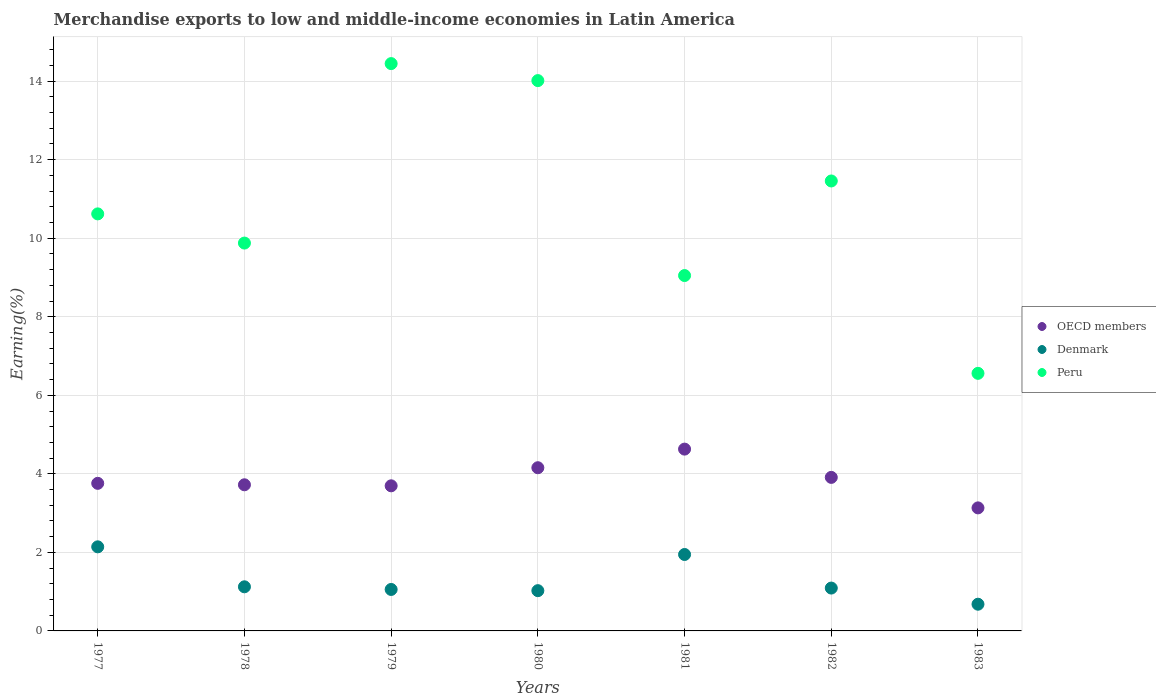What is the percentage of amount earned from merchandise exports in OECD members in 1982?
Provide a short and direct response. 3.91. Across all years, what is the maximum percentage of amount earned from merchandise exports in OECD members?
Your answer should be compact. 4.63. Across all years, what is the minimum percentage of amount earned from merchandise exports in OECD members?
Offer a terse response. 3.13. In which year was the percentage of amount earned from merchandise exports in OECD members maximum?
Offer a very short reply. 1981. In which year was the percentage of amount earned from merchandise exports in OECD members minimum?
Make the answer very short. 1983. What is the total percentage of amount earned from merchandise exports in OECD members in the graph?
Offer a very short reply. 27. What is the difference between the percentage of amount earned from merchandise exports in Peru in 1980 and that in 1982?
Your answer should be very brief. 2.56. What is the difference between the percentage of amount earned from merchandise exports in Peru in 1980 and the percentage of amount earned from merchandise exports in Denmark in 1982?
Make the answer very short. 12.92. What is the average percentage of amount earned from merchandise exports in Peru per year?
Ensure brevity in your answer.  10.86. In the year 1977, what is the difference between the percentage of amount earned from merchandise exports in Denmark and percentage of amount earned from merchandise exports in OECD members?
Provide a succinct answer. -1.62. What is the ratio of the percentage of amount earned from merchandise exports in OECD members in 1979 to that in 1983?
Offer a terse response. 1.18. Is the percentage of amount earned from merchandise exports in Peru in 1979 less than that in 1982?
Your answer should be compact. No. Is the difference between the percentage of amount earned from merchandise exports in Denmark in 1979 and 1983 greater than the difference between the percentage of amount earned from merchandise exports in OECD members in 1979 and 1983?
Give a very brief answer. No. What is the difference between the highest and the second highest percentage of amount earned from merchandise exports in Denmark?
Provide a succinct answer. 0.2. What is the difference between the highest and the lowest percentage of amount earned from merchandise exports in Peru?
Make the answer very short. 7.89. In how many years, is the percentage of amount earned from merchandise exports in OECD members greater than the average percentage of amount earned from merchandise exports in OECD members taken over all years?
Give a very brief answer. 3. Is the sum of the percentage of amount earned from merchandise exports in Denmark in 1977 and 1980 greater than the maximum percentage of amount earned from merchandise exports in Peru across all years?
Offer a terse response. No. Does the percentage of amount earned from merchandise exports in Peru monotonically increase over the years?
Ensure brevity in your answer.  No. Is the percentage of amount earned from merchandise exports in Denmark strictly greater than the percentage of amount earned from merchandise exports in Peru over the years?
Offer a very short reply. No. Is the percentage of amount earned from merchandise exports in Peru strictly less than the percentage of amount earned from merchandise exports in Denmark over the years?
Make the answer very short. No. How many years are there in the graph?
Provide a succinct answer. 7. Does the graph contain any zero values?
Make the answer very short. No. Does the graph contain grids?
Offer a very short reply. Yes. What is the title of the graph?
Keep it short and to the point. Merchandise exports to low and middle-income economies in Latin America. What is the label or title of the Y-axis?
Keep it short and to the point. Earning(%). What is the Earning(%) of OECD members in 1977?
Offer a very short reply. 3.76. What is the Earning(%) of Denmark in 1977?
Keep it short and to the point. 2.14. What is the Earning(%) of Peru in 1977?
Offer a very short reply. 10.62. What is the Earning(%) in OECD members in 1978?
Your answer should be compact. 3.72. What is the Earning(%) in Denmark in 1978?
Your response must be concise. 1.12. What is the Earning(%) in Peru in 1978?
Keep it short and to the point. 9.88. What is the Earning(%) in OECD members in 1979?
Your answer should be compact. 3.7. What is the Earning(%) in Denmark in 1979?
Provide a short and direct response. 1.06. What is the Earning(%) in Peru in 1979?
Offer a terse response. 14.45. What is the Earning(%) in OECD members in 1980?
Keep it short and to the point. 4.16. What is the Earning(%) in Denmark in 1980?
Ensure brevity in your answer.  1.03. What is the Earning(%) in Peru in 1980?
Your answer should be very brief. 14.01. What is the Earning(%) of OECD members in 1981?
Provide a succinct answer. 4.63. What is the Earning(%) in Denmark in 1981?
Your answer should be compact. 1.95. What is the Earning(%) in Peru in 1981?
Provide a short and direct response. 9.05. What is the Earning(%) in OECD members in 1982?
Provide a succinct answer. 3.91. What is the Earning(%) in Denmark in 1982?
Offer a very short reply. 1.09. What is the Earning(%) in Peru in 1982?
Your answer should be very brief. 11.46. What is the Earning(%) in OECD members in 1983?
Give a very brief answer. 3.13. What is the Earning(%) of Denmark in 1983?
Offer a very short reply. 0.68. What is the Earning(%) in Peru in 1983?
Offer a terse response. 6.56. Across all years, what is the maximum Earning(%) in OECD members?
Your answer should be compact. 4.63. Across all years, what is the maximum Earning(%) in Denmark?
Your answer should be compact. 2.14. Across all years, what is the maximum Earning(%) in Peru?
Provide a succinct answer. 14.45. Across all years, what is the minimum Earning(%) in OECD members?
Ensure brevity in your answer.  3.13. Across all years, what is the minimum Earning(%) in Denmark?
Make the answer very short. 0.68. Across all years, what is the minimum Earning(%) of Peru?
Keep it short and to the point. 6.56. What is the total Earning(%) of OECD members in the graph?
Provide a succinct answer. 27. What is the total Earning(%) in Denmark in the graph?
Make the answer very short. 9.06. What is the total Earning(%) of Peru in the graph?
Give a very brief answer. 76.03. What is the difference between the Earning(%) in OECD members in 1977 and that in 1978?
Keep it short and to the point. 0.04. What is the difference between the Earning(%) of Denmark in 1977 and that in 1978?
Your response must be concise. 1.02. What is the difference between the Earning(%) in Peru in 1977 and that in 1978?
Your answer should be compact. 0.74. What is the difference between the Earning(%) in OECD members in 1977 and that in 1979?
Offer a very short reply. 0.06. What is the difference between the Earning(%) of Denmark in 1977 and that in 1979?
Offer a very short reply. 1.09. What is the difference between the Earning(%) in Peru in 1977 and that in 1979?
Your response must be concise. -3.83. What is the difference between the Earning(%) of OECD members in 1977 and that in 1980?
Give a very brief answer. -0.4. What is the difference between the Earning(%) of Denmark in 1977 and that in 1980?
Ensure brevity in your answer.  1.12. What is the difference between the Earning(%) in Peru in 1977 and that in 1980?
Your answer should be compact. -3.39. What is the difference between the Earning(%) in OECD members in 1977 and that in 1981?
Your answer should be very brief. -0.87. What is the difference between the Earning(%) of Denmark in 1977 and that in 1981?
Give a very brief answer. 0.2. What is the difference between the Earning(%) in Peru in 1977 and that in 1981?
Make the answer very short. 1.57. What is the difference between the Earning(%) of OECD members in 1977 and that in 1982?
Make the answer very short. -0.15. What is the difference between the Earning(%) of Peru in 1977 and that in 1982?
Your answer should be very brief. -0.84. What is the difference between the Earning(%) in OECD members in 1977 and that in 1983?
Ensure brevity in your answer.  0.63. What is the difference between the Earning(%) in Denmark in 1977 and that in 1983?
Make the answer very short. 1.46. What is the difference between the Earning(%) in Peru in 1977 and that in 1983?
Keep it short and to the point. 4.06. What is the difference between the Earning(%) of OECD members in 1978 and that in 1979?
Provide a succinct answer. 0.03. What is the difference between the Earning(%) in Denmark in 1978 and that in 1979?
Offer a very short reply. 0.07. What is the difference between the Earning(%) of Peru in 1978 and that in 1979?
Your response must be concise. -4.57. What is the difference between the Earning(%) of OECD members in 1978 and that in 1980?
Make the answer very short. -0.43. What is the difference between the Earning(%) in Denmark in 1978 and that in 1980?
Make the answer very short. 0.1. What is the difference between the Earning(%) of Peru in 1978 and that in 1980?
Your response must be concise. -4.14. What is the difference between the Earning(%) of OECD members in 1978 and that in 1981?
Provide a succinct answer. -0.91. What is the difference between the Earning(%) in Denmark in 1978 and that in 1981?
Your answer should be compact. -0.82. What is the difference between the Earning(%) of Peru in 1978 and that in 1981?
Give a very brief answer. 0.83. What is the difference between the Earning(%) in OECD members in 1978 and that in 1982?
Ensure brevity in your answer.  -0.19. What is the difference between the Earning(%) in Denmark in 1978 and that in 1982?
Your answer should be compact. 0.03. What is the difference between the Earning(%) in Peru in 1978 and that in 1982?
Your answer should be very brief. -1.58. What is the difference between the Earning(%) of OECD members in 1978 and that in 1983?
Ensure brevity in your answer.  0.59. What is the difference between the Earning(%) in Denmark in 1978 and that in 1983?
Provide a short and direct response. 0.44. What is the difference between the Earning(%) of Peru in 1978 and that in 1983?
Your answer should be very brief. 3.32. What is the difference between the Earning(%) in OECD members in 1979 and that in 1980?
Keep it short and to the point. -0.46. What is the difference between the Earning(%) of Denmark in 1979 and that in 1980?
Your response must be concise. 0.03. What is the difference between the Earning(%) in Peru in 1979 and that in 1980?
Make the answer very short. 0.43. What is the difference between the Earning(%) in OECD members in 1979 and that in 1981?
Make the answer very short. -0.93. What is the difference between the Earning(%) in Denmark in 1979 and that in 1981?
Give a very brief answer. -0.89. What is the difference between the Earning(%) in Peru in 1979 and that in 1981?
Your answer should be compact. 5.4. What is the difference between the Earning(%) of OECD members in 1979 and that in 1982?
Your response must be concise. -0.21. What is the difference between the Earning(%) of Denmark in 1979 and that in 1982?
Make the answer very short. -0.04. What is the difference between the Earning(%) in Peru in 1979 and that in 1982?
Keep it short and to the point. 2.99. What is the difference between the Earning(%) of OECD members in 1979 and that in 1983?
Keep it short and to the point. 0.56. What is the difference between the Earning(%) of Denmark in 1979 and that in 1983?
Provide a succinct answer. 0.38. What is the difference between the Earning(%) of Peru in 1979 and that in 1983?
Make the answer very short. 7.89. What is the difference between the Earning(%) of OECD members in 1980 and that in 1981?
Make the answer very short. -0.47. What is the difference between the Earning(%) of Denmark in 1980 and that in 1981?
Your answer should be compact. -0.92. What is the difference between the Earning(%) of Peru in 1980 and that in 1981?
Your response must be concise. 4.96. What is the difference between the Earning(%) of OECD members in 1980 and that in 1982?
Make the answer very short. 0.25. What is the difference between the Earning(%) in Denmark in 1980 and that in 1982?
Make the answer very short. -0.07. What is the difference between the Earning(%) in Peru in 1980 and that in 1982?
Offer a very short reply. 2.56. What is the difference between the Earning(%) of OECD members in 1980 and that in 1983?
Offer a very short reply. 1.02. What is the difference between the Earning(%) in Denmark in 1980 and that in 1983?
Make the answer very short. 0.35. What is the difference between the Earning(%) in Peru in 1980 and that in 1983?
Keep it short and to the point. 7.45. What is the difference between the Earning(%) in OECD members in 1981 and that in 1982?
Ensure brevity in your answer.  0.72. What is the difference between the Earning(%) of Denmark in 1981 and that in 1982?
Keep it short and to the point. 0.85. What is the difference between the Earning(%) in Peru in 1981 and that in 1982?
Provide a short and direct response. -2.41. What is the difference between the Earning(%) of OECD members in 1981 and that in 1983?
Make the answer very short. 1.5. What is the difference between the Earning(%) of Denmark in 1981 and that in 1983?
Give a very brief answer. 1.27. What is the difference between the Earning(%) of Peru in 1981 and that in 1983?
Give a very brief answer. 2.49. What is the difference between the Earning(%) of OECD members in 1982 and that in 1983?
Your response must be concise. 0.78. What is the difference between the Earning(%) of Denmark in 1982 and that in 1983?
Provide a succinct answer. 0.41. What is the difference between the Earning(%) of Peru in 1982 and that in 1983?
Offer a very short reply. 4.9. What is the difference between the Earning(%) in OECD members in 1977 and the Earning(%) in Denmark in 1978?
Your answer should be compact. 2.63. What is the difference between the Earning(%) of OECD members in 1977 and the Earning(%) of Peru in 1978?
Provide a succinct answer. -6.12. What is the difference between the Earning(%) in Denmark in 1977 and the Earning(%) in Peru in 1978?
Offer a terse response. -7.74. What is the difference between the Earning(%) of OECD members in 1977 and the Earning(%) of Denmark in 1979?
Your answer should be compact. 2.7. What is the difference between the Earning(%) in OECD members in 1977 and the Earning(%) in Peru in 1979?
Your answer should be compact. -10.69. What is the difference between the Earning(%) in Denmark in 1977 and the Earning(%) in Peru in 1979?
Your response must be concise. -12.31. What is the difference between the Earning(%) in OECD members in 1977 and the Earning(%) in Denmark in 1980?
Your answer should be very brief. 2.73. What is the difference between the Earning(%) of OECD members in 1977 and the Earning(%) of Peru in 1980?
Provide a succinct answer. -10.26. What is the difference between the Earning(%) in Denmark in 1977 and the Earning(%) in Peru in 1980?
Keep it short and to the point. -11.87. What is the difference between the Earning(%) of OECD members in 1977 and the Earning(%) of Denmark in 1981?
Provide a short and direct response. 1.81. What is the difference between the Earning(%) in OECD members in 1977 and the Earning(%) in Peru in 1981?
Provide a short and direct response. -5.29. What is the difference between the Earning(%) in Denmark in 1977 and the Earning(%) in Peru in 1981?
Your answer should be very brief. -6.91. What is the difference between the Earning(%) of OECD members in 1977 and the Earning(%) of Denmark in 1982?
Keep it short and to the point. 2.67. What is the difference between the Earning(%) of OECD members in 1977 and the Earning(%) of Peru in 1982?
Provide a short and direct response. -7.7. What is the difference between the Earning(%) in Denmark in 1977 and the Earning(%) in Peru in 1982?
Make the answer very short. -9.32. What is the difference between the Earning(%) in OECD members in 1977 and the Earning(%) in Denmark in 1983?
Ensure brevity in your answer.  3.08. What is the difference between the Earning(%) of OECD members in 1977 and the Earning(%) of Peru in 1983?
Provide a succinct answer. -2.8. What is the difference between the Earning(%) in Denmark in 1977 and the Earning(%) in Peru in 1983?
Make the answer very short. -4.42. What is the difference between the Earning(%) in OECD members in 1978 and the Earning(%) in Denmark in 1979?
Provide a short and direct response. 2.67. What is the difference between the Earning(%) in OECD members in 1978 and the Earning(%) in Peru in 1979?
Give a very brief answer. -10.73. What is the difference between the Earning(%) of Denmark in 1978 and the Earning(%) of Peru in 1979?
Provide a succinct answer. -13.32. What is the difference between the Earning(%) in OECD members in 1978 and the Earning(%) in Denmark in 1980?
Give a very brief answer. 2.7. What is the difference between the Earning(%) of OECD members in 1978 and the Earning(%) of Peru in 1980?
Offer a very short reply. -10.29. What is the difference between the Earning(%) in Denmark in 1978 and the Earning(%) in Peru in 1980?
Provide a short and direct response. -12.89. What is the difference between the Earning(%) in OECD members in 1978 and the Earning(%) in Denmark in 1981?
Ensure brevity in your answer.  1.78. What is the difference between the Earning(%) of OECD members in 1978 and the Earning(%) of Peru in 1981?
Make the answer very short. -5.33. What is the difference between the Earning(%) of Denmark in 1978 and the Earning(%) of Peru in 1981?
Give a very brief answer. -7.93. What is the difference between the Earning(%) of OECD members in 1978 and the Earning(%) of Denmark in 1982?
Provide a succinct answer. 2.63. What is the difference between the Earning(%) of OECD members in 1978 and the Earning(%) of Peru in 1982?
Offer a terse response. -7.74. What is the difference between the Earning(%) of Denmark in 1978 and the Earning(%) of Peru in 1982?
Keep it short and to the point. -10.33. What is the difference between the Earning(%) of OECD members in 1978 and the Earning(%) of Denmark in 1983?
Give a very brief answer. 3.04. What is the difference between the Earning(%) in OECD members in 1978 and the Earning(%) in Peru in 1983?
Offer a terse response. -2.84. What is the difference between the Earning(%) of Denmark in 1978 and the Earning(%) of Peru in 1983?
Your answer should be compact. -5.44. What is the difference between the Earning(%) of OECD members in 1979 and the Earning(%) of Denmark in 1980?
Provide a succinct answer. 2.67. What is the difference between the Earning(%) in OECD members in 1979 and the Earning(%) in Peru in 1980?
Provide a short and direct response. -10.32. What is the difference between the Earning(%) of Denmark in 1979 and the Earning(%) of Peru in 1980?
Keep it short and to the point. -12.96. What is the difference between the Earning(%) in OECD members in 1979 and the Earning(%) in Denmark in 1981?
Ensure brevity in your answer.  1.75. What is the difference between the Earning(%) of OECD members in 1979 and the Earning(%) of Peru in 1981?
Offer a very short reply. -5.35. What is the difference between the Earning(%) of Denmark in 1979 and the Earning(%) of Peru in 1981?
Offer a terse response. -7.99. What is the difference between the Earning(%) of OECD members in 1979 and the Earning(%) of Denmark in 1982?
Make the answer very short. 2.6. What is the difference between the Earning(%) in OECD members in 1979 and the Earning(%) in Peru in 1982?
Your answer should be compact. -7.76. What is the difference between the Earning(%) of Denmark in 1979 and the Earning(%) of Peru in 1982?
Make the answer very short. -10.4. What is the difference between the Earning(%) in OECD members in 1979 and the Earning(%) in Denmark in 1983?
Your response must be concise. 3.02. What is the difference between the Earning(%) in OECD members in 1979 and the Earning(%) in Peru in 1983?
Keep it short and to the point. -2.86. What is the difference between the Earning(%) of Denmark in 1979 and the Earning(%) of Peru in 1983?
Offer a very short reply. -5.5. What is the difference between the Earning(%) of OECD members in 1980 and the Earning(%) of Denmark in 1981?
Your response must be concise. 2.21. What is the difference between the Earning(%) of OECD members in 1980 and the Earning(%) of Peru in 1981?
Your answer should be compact. -4.89. What is the difference between the Earning(%) in Denmark in 1980 and the Earning(%) in Peru in 1981?
Give a very brief answer. -8.02. What is the difference between the Earning(%) in OECD members in 1980 and the Earning(%) in Denmark in 1982?
Your answer should be very brief. 3.06. What is the difference between the Earning(%) in OECD members in 1980 and the Earning(%) in Peru in 1982?
Make the answer very short. -7.3. What is the difference between the Earning(%) of Denmark in 1980 and the Earning(%) of Peru in 1982?
Your response must be concise. -10.43. What is the difference between the Earning(%) in OECD members in 1980 and the Earning(%) in Denmark in 1983?
Keep it short and to the point. 3.48. What is the difference between the Earning(%) of OECD members in 1980 and the Earning(%) of Peru in 1983?
Your answer should be very brief. -2.4. What is the difference between the Earning(%) of Denmark in 1980 and the Earning(%) of Peru in 1983?
Give a very brief answer. -5.53. What is the difference between the Earning(%) of OECD members in 1981 and the Earning(%) of Denmark in 1982?
Ensure brevity in your answer.  3.54. What is the difference between the Earning(%) of OECD members in 1981 and the Earning(%) of Peru in 1982?
Provide a succinct answer. -6.83. What is the difference between the Earning(%) in Denmark in 1981 and the Earning(%) in Peru in 1982?
Provide a succinct answer. -9.51. What is the difference between the Earning(%) of OECD members in 1981 and the Earning(%) of Denmark in 1983?
Ensure brevity in your answer.  3.95. What is the difference between the Earning(%) of OECD members in 1981 and the Earning(%) of Peru in 1983?
Provide a succinct answer. -1.93. What is the difference between the Earning(%) in Denmark in 1981 and the Earning(%) in Peru in 1983?
Offer a terse response. -4.61. What is the difference between the Earning(%) in OECD members in 1982 and the Earning(%) in Denmark in 1983?
Offer a very short reply. 3.23. What is the difference between the Earning(%) of OECD members in 1982 and the Earning(%) of Peru in 1983?
Make the answer very short. -2.65. What is the difference between the Earning(%) in Denmark in 1982 and the Earning(%) in Peru in 1983?
Your answer should be very brief. -5.47. What is the average Earning(%) of OECD members per year?
Keep it short and to the point. 3.86. What is the average Earning(%) of Denmark per year?
Make the answer very short. 1.29. What is the average Earning(%) in Peru per year?
Ensure brevity in your answer.  10.86. In the year 1977, what is the difference between the Earning(%) in OECD members and Earning(%) in Denmark?
Offer a very short reply. 1.62. In the year 1977, what is the difference between the Earning(%) in OECD members and Earning(%) in Peru?
Offer a very short reply. -6.86. In the year 1977, what is the difference between the Earning(%) in Denmark and Earning(%) in Peru?
Give a very brief answer. -8.48. In the year 1978, what is the difference between the Earning(%) of OECD members and Earning(%) of Denmark?
Offer a very short reply. 2.6. In the year 1978, what is the difference between the Earning(%) in OECD members and Earning(%) in Peru?
Provide a succinct answer. -6.16. In the year 1978, what is the difference between the Earning(%) of Denmark and Earning(%) of Peru?
Your answer should be compact. -8.75. In the year 1979, what is the difference between the Earning(%) of OECD members and Earning(%) of Denmark?
Keep it short and to the point. 2.64. In the year 1979, what is the difference between the Earning(%) in OECD members and Earning(%) in Peru?
Make the answer very short. -10.75. In the year 1979, what is the difference between the Earning(%) of Denmark and Earning(%) of Peru?
Provide a succinct answer. -13.39. In the year 1980, what is the difference between the Earning(%) of OECD members and Earning(%) of Denmark?
Keep it short and to the point. 3.13. In the year 1980, what is the difference between the Earning(%) of OECD members and Earning(%) of Peru?
Give a very brief answer. -9.86. In the year 1980, what is the difference between the Earning(%) of Denmark and Earning(%) of Peru?
Provide a succinct answer. -12.99. In the year 1981, what is the difference between the Earning(%) in OECD members and Earning(%) in Denmark?
Provide a succinct answer. 2.68. In the year 1981, what is the difference between the Earning(%) in OECD members and Earning(%) in Peru?
Offer a very short reply. -4.42. In the year 1981, what is the difference between the Earning(%) of Denmark and Earning(%) of Peru?
Your answer should be very brief. -7.1. In the year 1982, what is the difference between the Earning(%) of OECD members and Earning(%) of Denmark?
Keep it short and to the point. 2.82. In the year 1982, what is the difference between the Earning(%) of OECD members and Earning(%) of Peru?
Give a very brief answer. -7.55. In the year 1982, what is the difference between the Earning(%) in Denmark and Earning(%) in Peru?
Provide a succinct answer. -10.37. In the year 1983, what is the difference between the Earning(%) of OECD members and Earning(%) of Denmark?
Offer a terse response. 2.45. In the year 1983, what is the difference between the Earning(%) of OECD members and Earning(%) of Peru?
Your answer should be very brief. -3.43. In the year 1983, what is the difference between the Earning(%) in Denmark and Earning(%) in Peru?
Offer a very short reply. -5.88. What is the ratio of the Earning(%) of OECD members in 1977 to that in 1978?
Your response must be concise. 1.01. What is the ratio of the Earning(%) of Denmark in 1977 to that in 1978?
Your answer should be compact. 1.91. What is the ratio of the Earning(%) of Peru in 1977 to that in 1978?
Make the answer very short. 1.08. What is the ratio of the Earning(%) in OECD members in 1977 to that in 1979?
Your answer should be very brief. 1.02. What is the ratio of the Earning(%) of Denmark in 1977 to that in 1979?
Your answer should be compact. 2.03. What is the ratio of the Earning(%) of Peru in 1977 to that in 1979?
Offer a terse response. 0.74. What is the ratio of the Earning(%) in OECD members in 1977 to that in 1980?
Make the answer very short. 0.9. What is the ratio of the Earning(%) of Denmark in 1977 to that in 1980?
Offer a terse response. 2.09. What is the ratio of the Earning(%) in Peru in 1977 to that in 1980?
Offer a terse response. 0.76. What is the ratio of the Earning(%) in OECD members in 1977 to that in 1981?
Give a very brief answer. 0.81. What is the ratio of the Earning(%) of Denmark in 1977 to that in 1981?
Your answer should be compact. 1.1. What is the ratio of the Earning(%) of Peru in 1977 to that in 1981?
Give a very brief answer. 1.17. What is the ratio of the Earning(%) in OECD members in 1977 to that in 1982?
Offer a very short reply. 0.96. What is the ratio of the Earning(%) of Denmark in 1977 to that in 1982?
Make the answer very short. 1.96. What is the ratio of the Earning(%) in Peru in 1977 to that in 1982?
Offer a terse response. 0.93. What is the ratio of the Earning(%) in OECD members in 1977 to that in 1983?
Provide a succinct answer. 1.2. What is the ratio of the Earning(%) of Denmark in 1977 to that in 1983?
Offer a terse response. 3.15. What is the ratio of the Earning(%) in Peru in 1977 to that in 1983?
Your answer should be compact. 1.62. What is the ratio of the Earning(%) of OECD members in 1978 to that in 1979?
Your answer should be very brief. 1.01. What is the ratio of the Earning(%) of Denmark in 1978 to that in 1979?
Give a very brief answer. 1.06. What is the ratio of the Earning(%) in Peru in 1978 to that in 1979?
Offer a terse response. 0.68. What is the ratio of the Earning(%) in OECD members in 1978 to that in 1980?
Ensure brevity in your answer.  0.9. What is the ratio of the Earning(%) in Denmark in 1978 to that in 1980?
Give a very brief answer. 1.1. What is the ratio of the Earning(%) of Peru in 1978 to that in 1980?
Your answer should be very brief. 0.7. What is the ratio of the Earning(%) in OECD members in 1978 to that in 1981?
Keep it short and to the point. 0.8. What is the ratio of the Earning(%) in Denmark in 1978 to that in 1981?
Offer a terse response. 0.58. What is the ratio of the Earning(%) of Peru in 1978 to that in 1981?
Offer a terse response. 1.09. What is the ratio of the Earning(%) of OECD members in 1978 to that in 1982?
Make the answer very short. 0.95. What is the ratio of the Earning(%) of Denmark in 1978 to that in 1982?
Your response must be concise. 1.03. What is the ratio of the Earning(%) in Peru in 1978 to that in 1982?
Your response must be concise. 0.86. What is the ratio of the Earning(%) of OECD members in 1978 to that in 1983?
Provide a succinct answer. 1.19. What is the ratio of the Earning(%) in Denmark in 1978 to that in 1983?
Your answer should be compact. 1.65. What is the ratio of the Earning(%) in Peru in 1978 to that in 1983?
Ensure brevity in your answer.  1.51. What is the ratio of the Earning(%) of OECD members in 1979 to that in 1980?
Your answer should be compact. 0.89. What is the ratio of the Earning(%) in Denmark in 1979 to that in 1980?
Your answer should be very brief. 1.03. What is the ratio of the Earning(%) in Peru in 1979 to that in 1980?
Ensure brevity in your answer.  1.03. What is the ratio of the Earning(%) of OECD members in 1979 to that in 1981?
Make the answer very short. 0.8. What is the ratio of the Earning(%) of Denmark in 1979 to that in 1981?
Offer a terse response. 0.54. What is the ratio of the Earning(%) in Peru in 1979 to that in 1981?
Make the answer very short. 1.6. What is the ratio of the Earning(%) of OECD members in 1979 to that in 1982?
Offer a terse response. 0.94. What is the ratio of the Earning(%) of Denmark in 1979 to that in 1982?
Your answer should be compact. 0.97. What is the ratio of the Earning(%) in Peru in 1979 to that in 1982?
Your answer should be very brief. 1.26. What is the ratio of the Earning(%) in OECD members in 1979 to that in 1983?
Give a very brief answer. 1.18. What is the ratio of the Earning(%) in Denmark in 1979 to that in 1983?
Give a very brief answer. 1.55. What is the ratio of the Earning(%) in Peru in 1979 to that in 1983?
Provide a short and direct response. 2.2. What is the ratio of the Earning(%) of OECD members in 1980 to that in 1981?
Your response must be concise. 0.9. What is the ratio of the Earning(%) in Denmark in 1980 to that in 1981?
Ensure brevity in your answer.  0.53. What is the ratio of the Earning(%) in Peru in 1980 to that in 1981?
Offer a very short reply. 1.55. What is the ratio of the Earning(%) in OECD members in 1980 to that in 1982?
Make the answer very short. 1.06. What is the ratio of the Earning(%) of Denmark in 1980 to that in 1982?
Keep it short and to the point. 0.94. What is the ratio of the Earning(%) in Peru in 1980 to that in 1982?
Make the answer very short. 1.22. What is the ratio of the Earning(%) in OECD members in 1980 to that in 1983?
Offer a terse response. 1.33. What is the ratio of the Earning(%) in Denmark in 1980 to that in 1983?
Offer a terse response. 1.51. What is the ratio of the Earning(%) in Peru in 1980 to that in 1983?
Ensure brevity in your answer.  2.14. What is the ratio of the Earning(%) in OECD members in 1981 to that in 1982?
Your answer should be compact. 1.18. What is the ratio of the Earning(%) in Denmark in 1981 to that in 1982?
Make the answer very short. 1.78. What is the ratio of the Earning(%) in Peru in 1981 to that in 1982?
Provide a short and direct response. 0.79. What is the ratio of the Earning(%) of OECD members in 1981 to that in 1983?
Give a very brief answer. 1.48. What is the ratio of the Earning(%) in Denmark in 1981 to that in 1983?
Make the answer very short. 2.86. What is the ratio of the Earning(%) of Peru in 1981 to that in 1983?
Give a very brief answer. 1.38. What is the ratio of the Earning(%) of OECD members in 1982 to that in 1983?
Give a very brief answer. 1.25. What is the ratio of the Earning(%) in Denmark in 1982 to that in 1983?
Your answer should be very brief. 1.6. What is the ratio of the Earning(%) in Peru in 1982 to that in 1983?
Ensure brevity in your answer.  1.75. What is the difference between the highest and the second highest Earning(%) of OECD members?
Offer a very short reply. 0.47. What is the difference between the highest and the second highest Earning(%) in Denmark?
Keep it short and to the point. 0.2. What is the difference between the highest and the second highest Earning(%) in Peru?
Offer a terse response. 0.43. What is the difference between the highest and the lowest Earning(%) in OECD members?
Give a very brief answer. 1.5. What is the difference between the highest and the lowest Earning(%) in Denmark?
Give a very brief answer. 1.46. What is the difference between the highest and the lowest Earning(%) in Peru?
Ensure brevity in your answer.  7.89. 